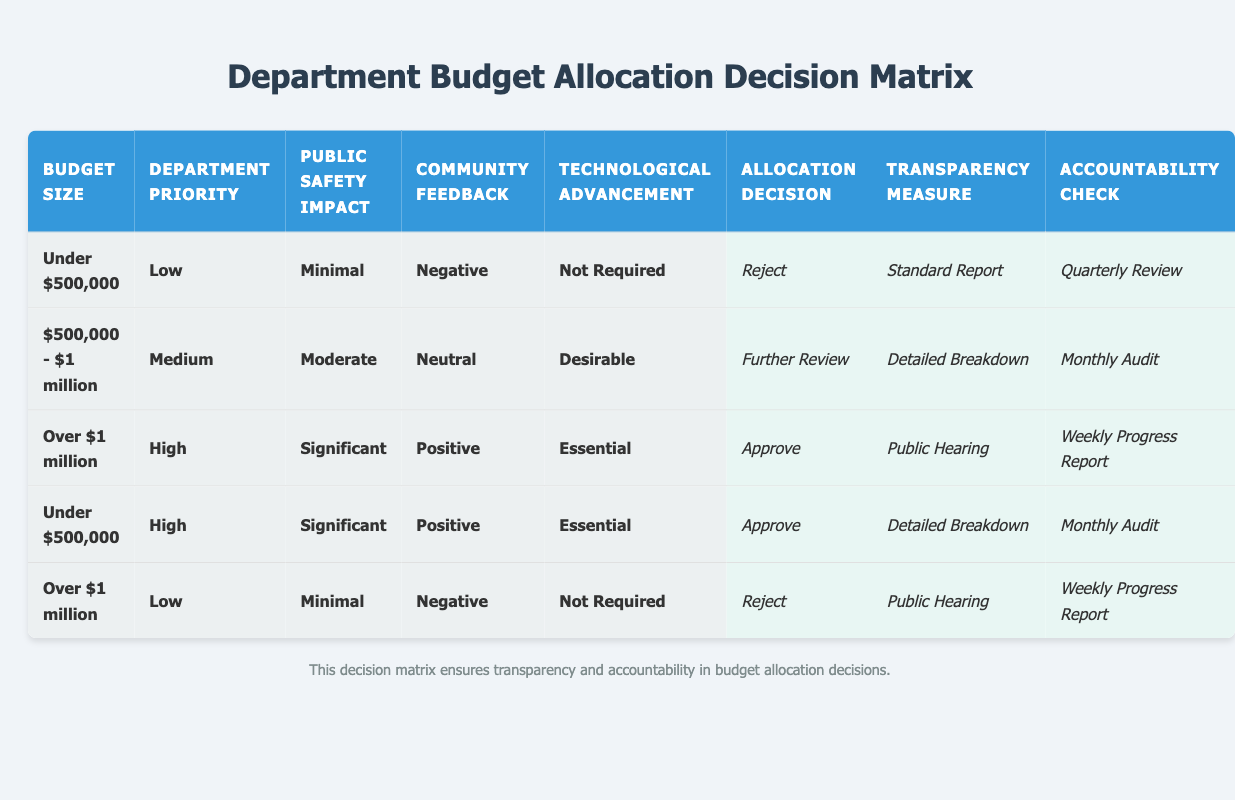What is the allocation decision for budgets under $500,000 with low priority? In the table, for the condition where the budget size is "Under $500,000" and the department priority is "Low," the allocation decision is "Reject."
Answer: Reject What transparency measure is associated with high priority budgets over $1 million? Referring to the table, when the budget size is "Over $1 million" and the department priority is "High," the transparency measure is "Public Hearing."
Answer: Public Hearing How many allocation decisions in the table result in an approval? By reviewing all rows in the table, there are two instances where the allocation decision is "Approve," one for the budget size "Over $1 million" with high priority and another for "Under $500,000" with high priority. Therefore, the total count is 2.
Answer: 2 Is there a scenario where a budget over $1 million has community feedback that is positive? Looking at the table, the entry for “Over $1 million” with "High" priority, "Significant" public safety impact, and "Positive" community feedback results in an "Approve" allocation decision. Thus, yes, there is such a scenario.
Answer: Yes What are the average transparency measures for medium priority budgets? There is one budget with a medium priority where the size is "$500,000 - $1 million," and the associated transparency measure is "Detailed Breakdown." Since there is only one instance, the average is just that one entry.
Answer: Detailed Breakdown What is the accountability check for budgets under $500,000 with significant public safety impact and positive feedback? In the table, for a budget size of "Under $500,000" with "High" priority and "Significant" public safety impact which also received "Positive" community feedback, the accountability check is "Monthly Audit."
Answer: Monthly Audit Are there any budget scenarios with negative community feedback that resulted in an approval? In examining the rows, both scenarios where community feedback is negative conclude with a "Reject" allocation decision. Therefore, there are no instances where negative feedback results in an approval.
Answer: No What is the difference in accountability checks between approved budgets and rejected budgets? The approved budgets have accountability checks of "Weekly Progress Report" and "Monthly Audit," while the rejected budgets have "Quarterly Review" and "Weekly Progress Report." To summarize, rejected budgets can have Quarterly checks while approved budgets might have Weekly or Monthly checks.
Answer: Varies What is the most common action taken in response to budgets under $500,000? By reviewing the entries in the table, all scenarios with a budget under $500,000 lead to actions of either "Reject" or "Approve." Specifically, the only two entries related to this budget size, one is a "Reject" and the other an "Approve." The "Reject" appears more frequently at one instance compared to the single approve action.
Answer: Reject 